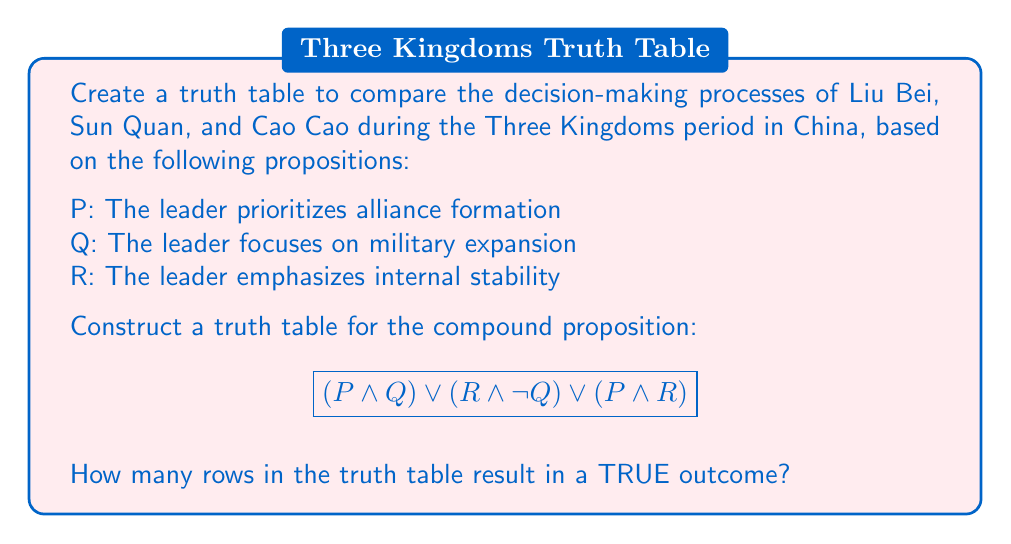Teach me how to tackle this problem. To solve this problem, we'll follow these steps:

1. Identify the number of variables: P, Q, and R (3 variables)
2. Determine the number of rows in the truth table: $2^3 = 8$ rows
3. Create the truth table with columns for P, Q, R, and the compound proposition
4. Evaluate the compound proposition for each row
5. Count the number of TRUE outcomes

Step 1-3: Create the truth table

| P | Q | R | $(P \land Q)$ | $(R \land \neg Q)$ | $(P \land R)$ | $(P \land Q) \lor (R \land \neg Q) \lor (P \land R)$ |
|---|---|---|---------------|---------------------|---------------|-------------------------------------------------------|
| T | T | T |       T       |         F           |       T       |                        T                              |
| T | T | F |       T       |         F           |       F       |                        T                              |
| T | F | T |       F       |         T           |       T       |                        T                              |
| T | F | F |       F       |         F           |       F       |                        F                              |
| F | T | T |       F       |         F           |       F       |                        F                              |
| F | T | F |       F       |         F           |       F       |                        F                              |
| F | F | T |       F       |         T           |       F       |                        T                              |
| F | F | F |       F       |         F           |       F       |                        F                              |

Step 4-5: Count the number of TRUE outcomes

From the truth table, we can see that there are 4 rows where the compound proposition evaluates to TRUE.

This result can be interpreted as follows:
- The decision-making process is TRUE when a leader prioritizes alliances and expansion (row 1)
- It's also TRUE when focusing on alliances and internal stability (row 2)
- Another TRUE outcome is when emphasizing internal stability without expansion (row 3)
- The final TRUE outcome is when prioritizing alliances and internal stability without expansion (row 7)

These outcomes reflect different strategies employed by Liu Bei, Sun Quan, and Cao Cao during the Three Kingdoms period, showcasing the complexity of their decision-making processes.
Answer: 4 